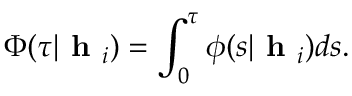<formula> <loc_0><loc_0><loc_500><loc_500>\Phi ( \tau | h _ { i } ) = \int _ { 0 } ^ { \tau } \phi ( s | h _ { i } ) d s .</formula> 